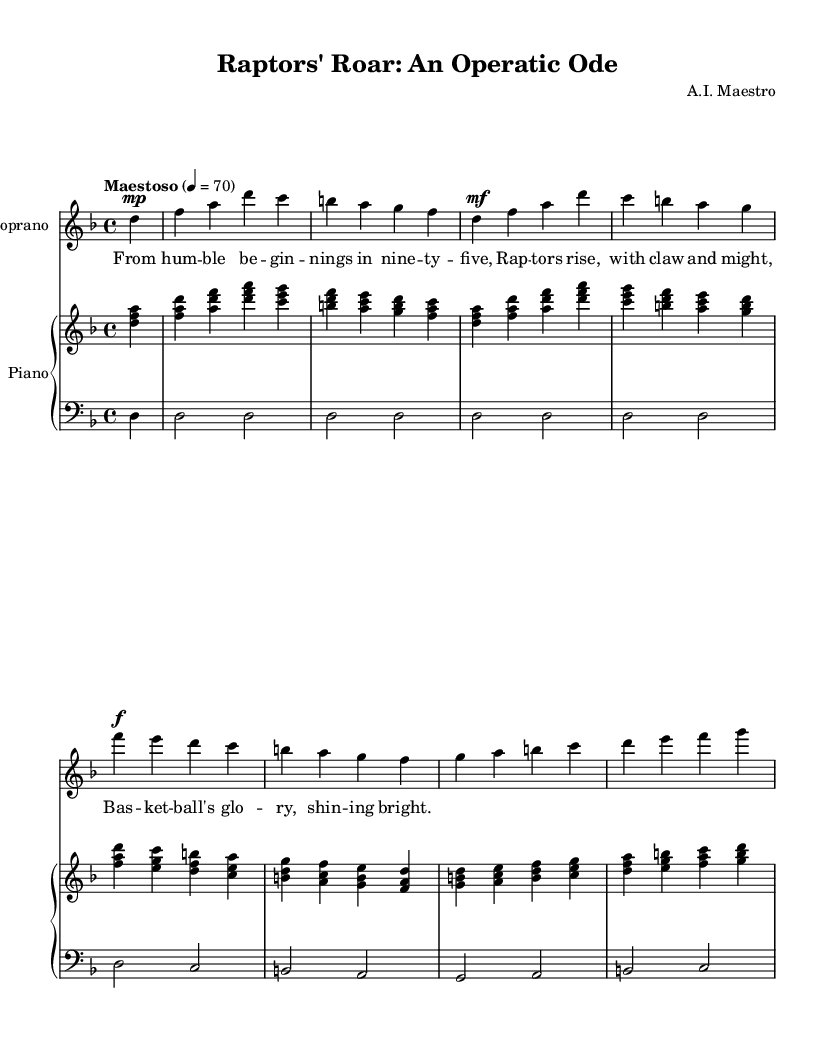What is the key signature of this music? The key signature is indicated by the presence of flats or sharps at the beginning of the staff. In this score, there are no sharps or flats, indicating the key of D minor, which has one flat.
Answer: D minor What is the time signature of this music? The time signature is shown at the beginning of the score after the key signature. It shows the number of beats in each measure. Here, the time signature is 4/4, meaning there are four beats per measure.
Answer: 4/4 What is the tempo marking of this music? The tempo is given in words above the staff, usually in Italian or English, and indicates the speed of the piece. In this score, the tempo marking is "Maestoso," which suggests it should be played majestically at a tempo of 70 beats per minute.
Answer: Maestoso How many measures are in the chorus section? The chorus section can be identified by its distinct lyrical and musical pattern which usually follows the verse. By counting the measures from the start of the chorus to the end, it is noted that there are eight measures in this specific section of the score.
Answer: Eight What type of voice is featured in this score? The score explicitly labels the voice part as "Soprano," which highlights that the music is written for a higher female vocal range commonly used in opera.
Answer: Soprano What is the dynamic marking for the introduction? Dynamic markings in music indicate the volume at which music should be played. In the introduction of this piece, the dynamic marking is "mp," which stands for mezzopiano, indicating a moderately soft volume.
Answer: Mezzopiano What is the thematic content expressed in the lyrics? The lyrics relate directly to the history and spirit of the Toronto Raptors, as they convey the journey of the franchise starting from humble beginnings and celebrating their success in basketball. The first line indicates the year they began, and the chorus highlights their rise.
Answer: Raptors rise, with claw and might 